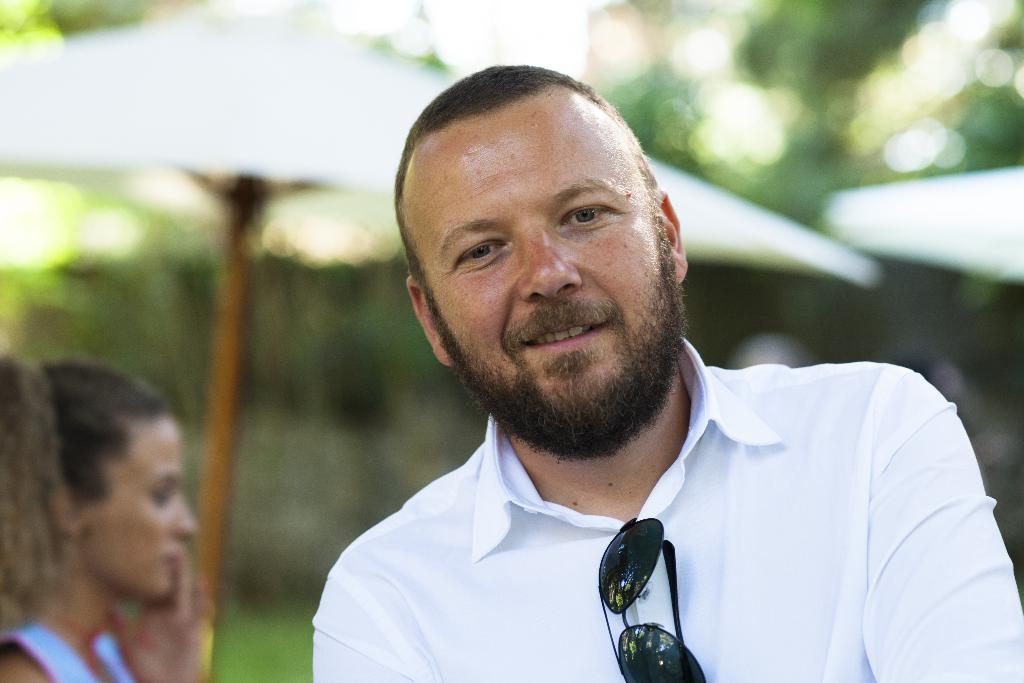Can you describe this image briefly? In the foreground of the image there is a person wearing white color shirt. In the background of the image there is a woman. There is a umbrella. There are trees. 